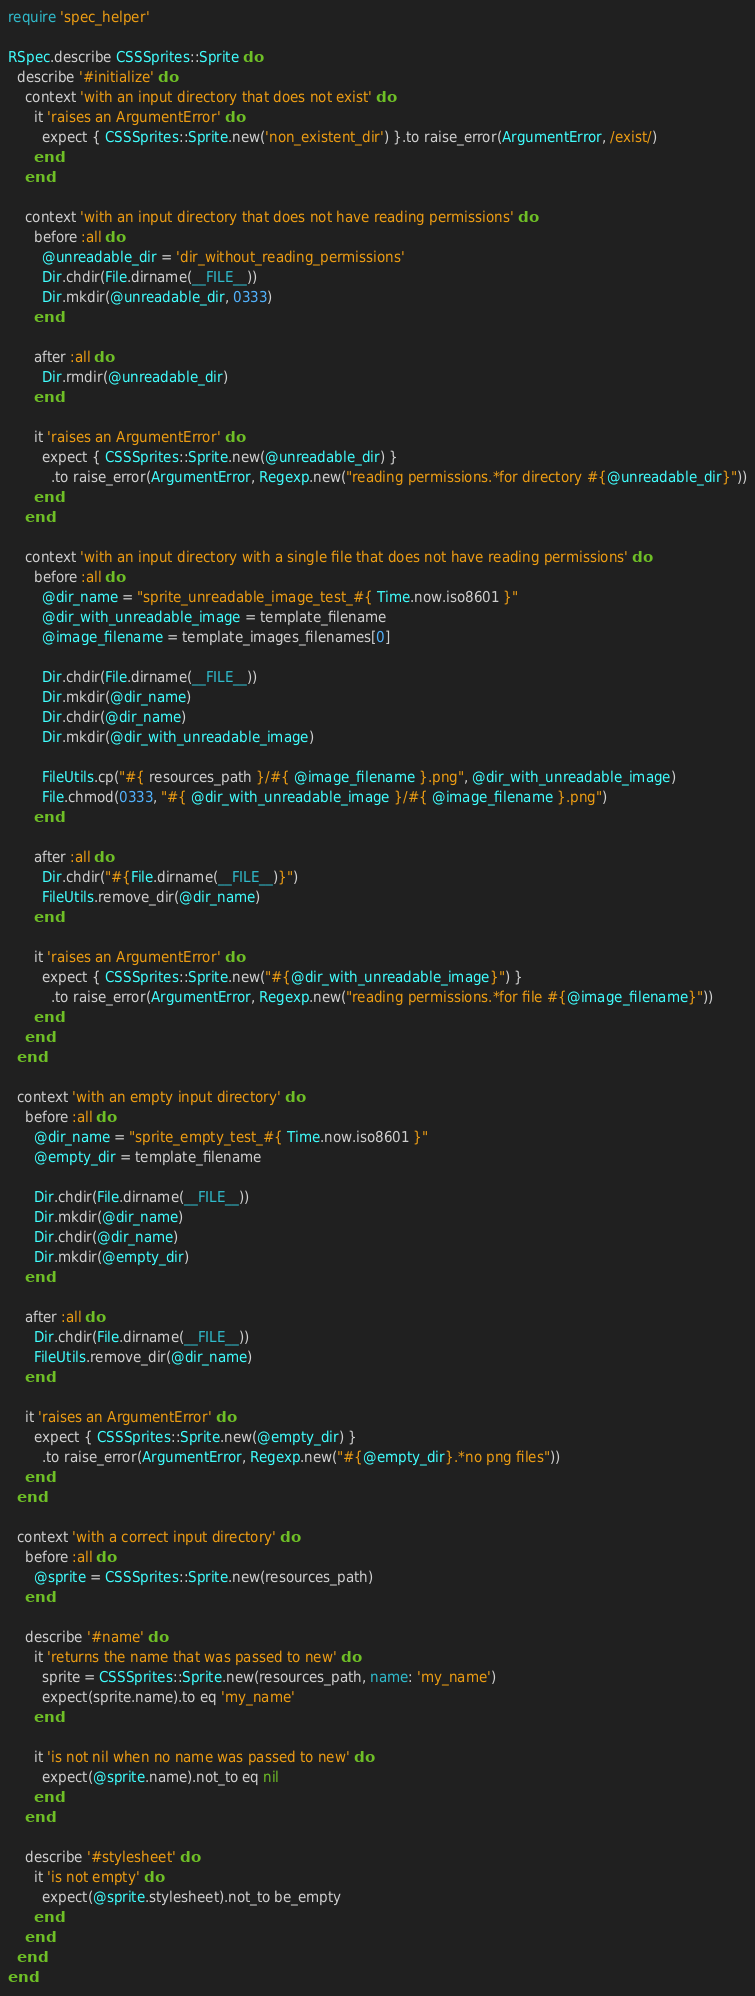<code> <loc_0><loc_0><loc_500><loc_500><_Ruby_>require 'spec_helper'

RSpec.describe CSSSprites::Sprite do
  describe '#initialize' do
    context 'with an input directory that does not exist' do
      it 'raises an ArgumentError' do
        expect { CSSSprites::Sprite.new('non_existent_dir') }.to raise_error(ArgumentError, /exist/)
      end
    end

    context 'with an input directory that does not have reading permissions' do
      before :all do
        @unreadable_dir = 'dir_without_reading_permissions'
        Dir.chdir(File.dirname(__FILE__))
        Dir.mkdir(@unreadable_dir, 0333)
      end

      after :all do
        Dir.rmdir(@unreadable_dir)
      end

      it 'raises an ArgumentError' do
        expect { CSSSprites::Sprite.new(@unreadable_dir) }
          .to raise_error(ArgumentError, Regexp.new("reading permissions.*for directory #{@unreadable_dir}"))
      end
    end

    context 'with an input directory with a single file that does not have reading permissions' do
      before :all do
        @dir_name = "sprite_unreadable_image_test_#{ Time.now.iso8601 }"
        @dir_with_unreadable_image = template_filename
        @image_filename = template_images_filenames[0]

        Dir.chdir(File.dirname(__FILE__))
        Dir.mkdir(@dir_name)
        Dir.chdir(@dir_name)
        Dir.mkdir(@dir_with_unreadable_image)

        FileUtils.cp("#{ resources_path }/#{ @image_filename }.png", @dir_with_unreadable_image)
        File.chmod(0333, "#{ @dir_with_unreadable_image }/#{ @image_filename }.png")
      end

      after :all do
        Dir.chdir("#{File.dirname(__FILE__)}")
        FileUtils.remove_dir(@dir_name)
      end

      it 'raises an ArgumentError' do
        expect { CSSSprites::Sprite.new("#{@dir_with_unreadable_image}") }
          .to raise_error(ArgumentError, Regexp.new("reading permissions.*for file #{@image_filename}"))
      end
    end
  end

  context 'with an empty input directory' do
    before :all do
      @dir_name = "sprite_empty_test_#{ Time.now.iso8601 }"
      @empty_dir = template_filename

      Dir.chdir(File.dirname(__FILE__))
      Dir.mkdir(@dir_name)
      Dir.chdir(@dir_name)
      Dir.mkdir(@empty_dir)
    end

    after :all do
      Dir.chdir(File.dirname(__FILE__))
      FileUtils.remove_dir(@dir_name)
    end

    it 'raises an ArgumentError' do
      expect { CSSSprites::Sprite.new(@empty_dir) }
        .to raise_error(ArgumentError, Regexp.new("#{@empty_dir}.*no png files"))
    end
  end

  context 'with a correct input directory' do
    before :all do
      @sprite = CSSSprites::Sprite.new(resources_path)
    end

    describe '#name' do
      it 'returns the name that was passed to new' do
        sprite = CSSSprites::Sprite.new(resources_path, name: 'my_name')
        expect(sprite.name).to eq 'my_name'
      end

      it 'is not nil when no name was passed to new' do
        expect(@sprite.name).not_to eq nil
      end
    end

    describe '#stylesheet' do
      it 'is not empty' do
        expect(@sprite.stylesheet).not_to be_empty
      end
    end
  end
end</code> 